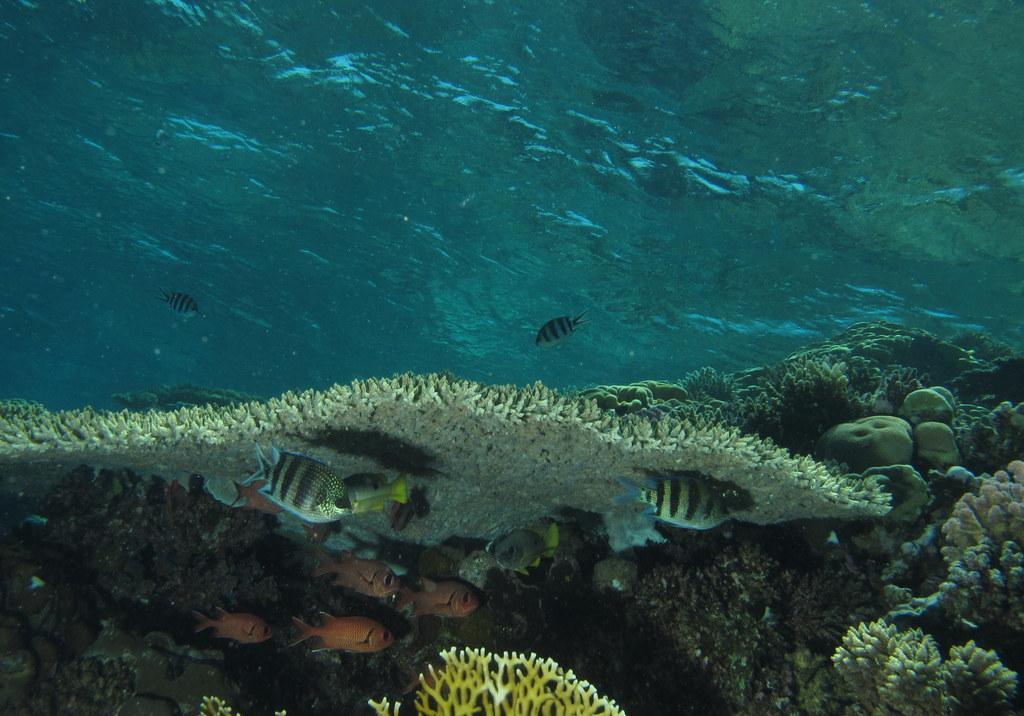Could you give a brief overview of what you see in this image? In this image I can see the fish and the aquatic plants inside the water. I can see the water in blue color. 